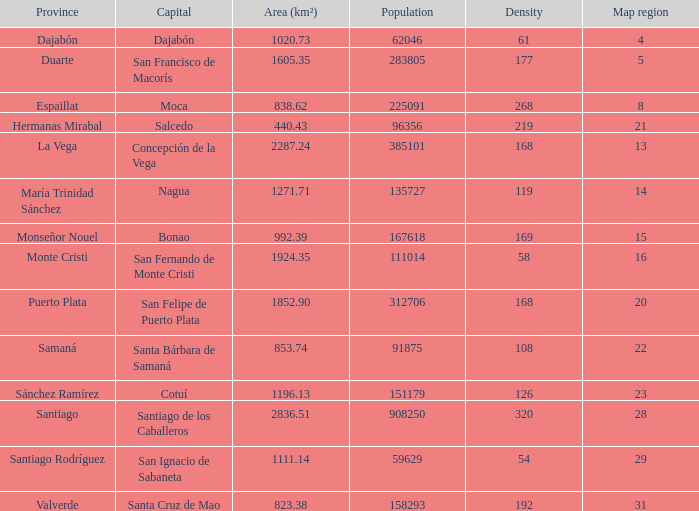Can you give me this table as a dict? {'header': ['Province', 'Capital', 'Area (km²)', 'Population', 'Density', 'Map region'], 'rows': [['Dajabón', 'Dajabón', '1020.73', '62046', '61', '4'], ['Duarte', 'San Francisco de Macorís', '1605.35', '283805', '177', '5'], ['Espaillat', 'Moca', '838.62', '225091', '268', '8'], ['Hermanas Mirabal', 'Salcedo', '440.43', '96356', '219', '21'], ['La Vega', 'Concepción de la Vega', '2287.24', '385101', '168', '13'], ['María Trinidad Sánchez', 'Nagua', '1271.71', '135727', '119', '14'], ['Monseñor Nouel', 'Bonao', '992.39', '167618', '169', '15'], ['Monte Cristi', 'San Fernando de Monte Cristi', '1924.35', '111014', '58', '16'], ['Puerto Plata', 'San Felipe de Puerto Plata', '1852.90', '312706', '168', '20'], ['Samaná', 'Santa Bárbara de Samaná', '853.74', '91875', '108', '22'], ['Sánchez Ramírez', 'Cotuí', '1196.13', '151179', '126', '23'], ['Santiago', 'Santiago de los Caballeros', '2836.51', '908250', '320', '28'], ['Santiago Rodríguez', 'San Ignacio de Sabaneta', '1111.14', '59629', '54', '29'], ['Valverde', 'Santa Cruz de Mao', '823.38', '158293', '192', '31']]} When considering monseñor nouel as the province, what is its area in square kilometers? 992.39. 